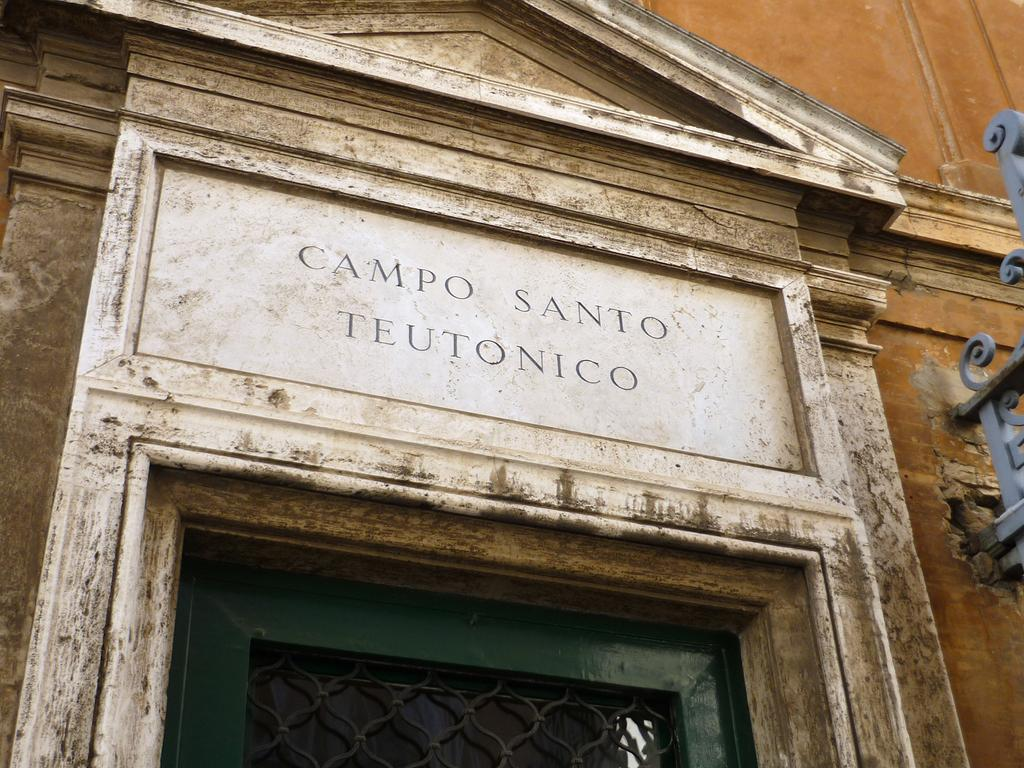What type of structure is visible in the image? There is a building in the image. Can you read the name of the building? The building has a name on it. What type of station is located near the building in the image? There is no station mentioned or visible in the image. What experience can be gained by visiting the building in the image? The provided facts do not mention any specific experiences related to the building. 